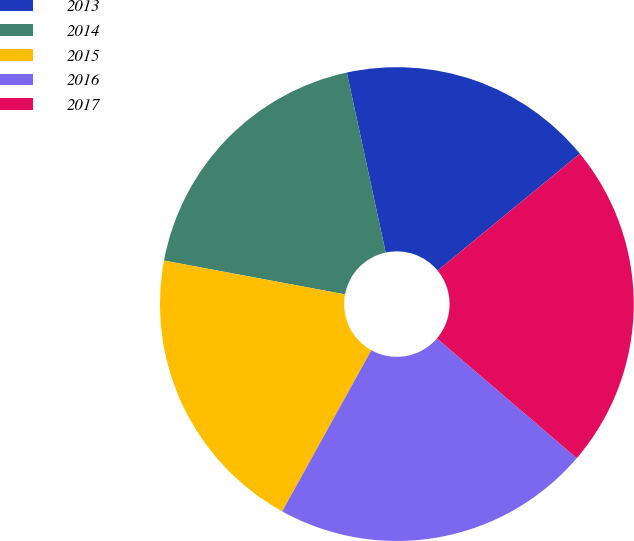<chart> <loc_0><loc_0><loc_500><loc_500><pie_chart><fcel>2013<fcel>2014<fcel>2015<fcel>2016<fcel>2017<nl><fcel>17.44%<fcel>18.67%<fcel>19.9%<fcel>21.77%<fcel>22.22%<nl></chart> 